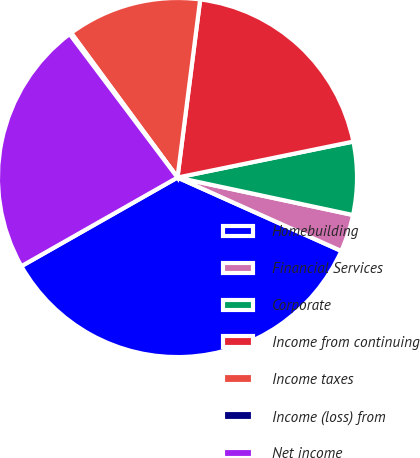<chart> <loc_0><loc_0><loc_500><loc_500><pie_chart><fcel>Homebuilding<fcel>Financial Services<fcel>Corporate<fcel>Income from continuing<fcel>Income taxes<fcel>Income (loss) from<fcel>Net income<nl><fcel>35.07%<fcel>3.36%<fcel>6.56%<fcel>19.77%<fcel>12.11%<fcel>0.17%<fcel>22.96%<nl></chart> 